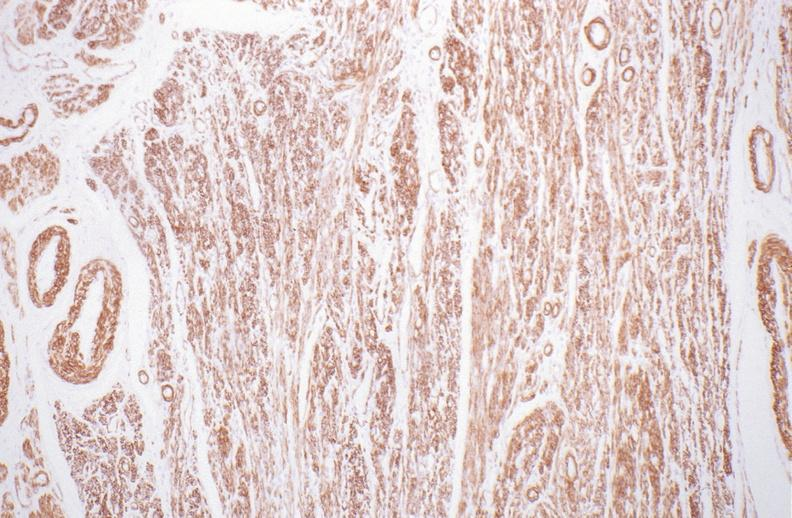do alpha smooth muscle actin immunohistochemical stain?
Answer the question using a single word or phrase. Yes 